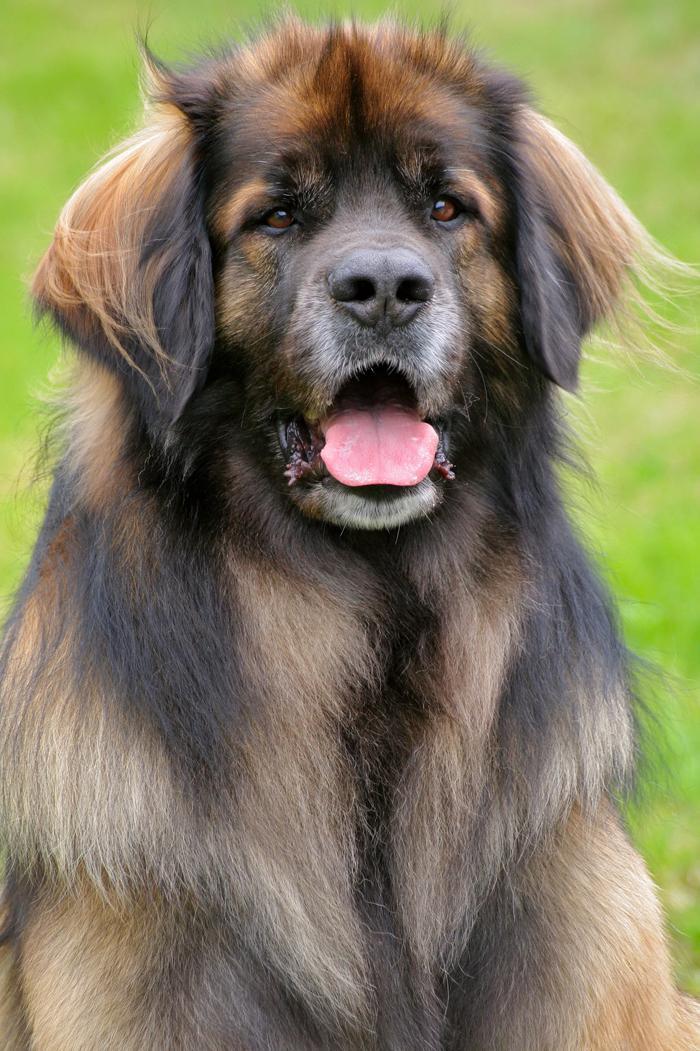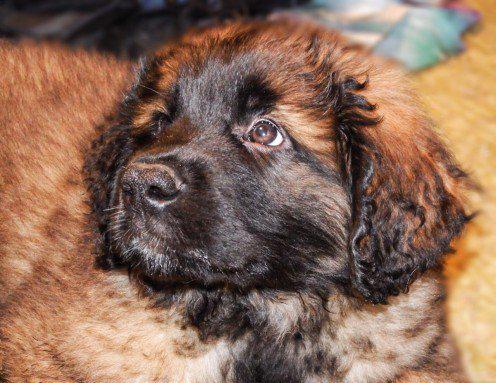The first image is the image on the left, the second image is the image on the right. Given the left and right images, does the statement "There are two dogs total." hold true? Answer yes or no. Yes. The first image is the image on the left, the second image is the image on the right. Assess this claim about the two images: "One image is shot indoors with furniture and one image is outdoors with grass.". Correct or not? Answer yes or no. No. 